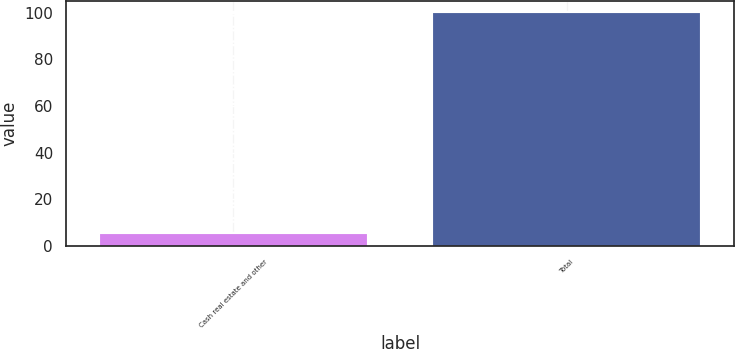<chart> <loc_0><loc_0><loc_500><loc_500><bar_chart><fcel>Cash real estate and other<fcel>Total<nl><fcel>5<fcel>100<nl></chart> 